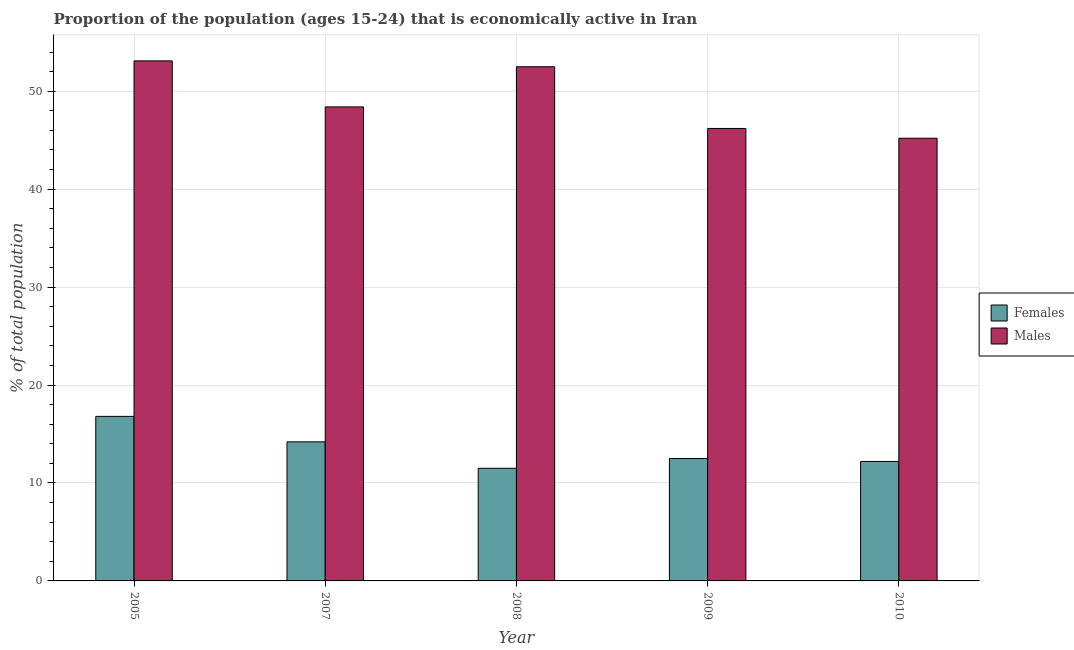How many different coloured bars are there?
Ensure brevity in your answer.  2. How many groups of bars are there?
Your answer should be compact. 5. Are the number of bars per tick equal to the number of legend labels?
Provide a succinct answer. Yes. How many bars are there on the 1st tick from the right?
Provide a short and direct response. 2. In how many cases, is the number of bars for a given year not equal to the number of legend labels?
Your answer should be compact. 0. What is the percentage of economically active male population in 2009?
Give a very brief answer. 46.2. Across all years, what is the maximum percentage of economically active male population?
Give a very brief answer. 53.1. In which year was the percentage of economically active female population maximum?
Offer a terse response. 2005. What is the total percentage of economically active male population in the graph?
Provide a short and direct response. 245.4. What is the difference between the percentage of economically active female population in 2005 and that in 2010?
Ensure brevity in your answer.  4.6. What is the difference between the percentage of economically active female population in 2005 and the percentage of economically active male population in 2009?
Your answer should be very brief. 4.3. What is the average percentage of economically active female population per year?
Give a very brief answer. 13.44. In the year 2010, what is the difference between the percentage of economically active male population and percentage of economically active female population?
Your answer should be very brief. 0. In how many years, is the percentage of economically active male population greater than 44 %?
Provide a succinct answer. 5. What is the ratio of the percentage of economically active male population in 2005 to that in 2009?
Keep it short and to the point. 1.15. Is the difference between the percentage of economically active male population in 2005 and 2010 greater than the difference between the percentage of economically active female population in 2005 and 2010?
Offer a very short reply. No. What is the difference between the highest and the second highest percentage of economically active male population?
Keep it short and to the point. 0.6. What is the difference between the highest and the lowest percentage of economically active female population?
Your answer should be very brief. 5.3. In how many years, is the percentage of economically active female population greater than the average percentage of economically active female population taken over all years?
Make the answer very short. 2. What does the 2nd bar from the left in 2005 represents?
Make the answer very short. Males. What does the 1st bar from the right in 2009 represents?
Your answer should be compact. Males. How many bars are there?
Offer a terse response. 10. Are all the bars in the graph horizontal?
Provide a succinct answer. No. Where does the legend appear in the graph?
Keep it short and to the point. Center right. How many legend labels are there?
Make the answer very short. 2. What is the title of the graph?
Provide a succinct answer. Proportion of the population (ages 15-24) that is economically active in Iran. What is the label or title of the X-axis?
Provide a short and direct response. Year. What is the label or title of the Y-axis?
Offer a terse response. % of total population. What is the % of total population in Females in 2005?
Your answer should be compact. 16.8. What is the % of total population of Males in 2005?
Your answer should be very brief. 53.1. What is the % of total population in Females in 2007?
Your answer should be compact. 14.2. What is the % of total population in Males in 2007?
Offer a terse response. 48.4. What is the % of total population in Females in 2008?
Your response must be concise. 11.5. What is the % of total population in Males in 2008?
Your answer should be compact. 52.5. What is the % of total population of Males in 2009?
Keep it short and to the point. 46.2. What is the % of total population in Females in 2010?
Provide a succinct answer. 12.2. What is the % of total population in Males in 2010?
Provide a succinct answer. 45.2. Across all years, what is the maximum % of total population in Females?
Your answer should be compact. 16.8. Across all years, what is the maximum % of total population of Males?
Offer a terse response. 53.1. Across all years, what is the minimum % of total population of Males?
Offer a terse response. 45.2. What is the total % of total population in Females in the graph?
Offer a very short reply. 67.2. What is the total % of total population of Males in the graph?
Your answer should be very brief. 245.4. What is the difference between the % of total population in Females in 2005 and that in 2007?
Offer a very short reply. 2.6. What is the difference between the % of total population of Males in 2005 and that in 2008?
Make the answer very short. 0.6. What is the difference between the % of total population of Males in 2005 and that in 2009?
Provide a succinct answer. 6.9. What is the difference between the % of total population in Females in 2005 and that in 2010?
Ensure brevity in your answer.  4.6. What is the difference between the % of total population of Females in 2007 and that in 2008?
Offer a very short reply. 2.7. What is the difference between the % of total population of Males in 2007 and that in 2008?
Ensure brevity in your answer.  -4.1. What is the difference between the % of total population in Males in 2007 and that in 2009?
Your answer should be very brief. 2.2. What is the difference between the % of total population of Females in 2008 and that in 2010?
Give a very brief answer. -0.7. What is the difference between the % of total population of Males in 2008 and that in 2010?
Make the answer very short. 7.3. What is the difference between the % of total population of Females in 2009 and that in 2010?
Offer a terse response. 0.3. What is the difference between the % of total population of Females in 2005 and the % of total population of Males in 2007?
Provide a succinct answer. -31.6. What is the difference between the % of total population of Females in 2005 and the % of total population of Males in 2008?
Offer a very short reply. -35.7. What is the difference between the % of total population in Females in 2005 and the % of total population in Males in 2009?
Offer a very short reply. -29.4. What is the difference between the % of total population in Females in 2005 and the % of total population in Males in 2010?
Keep it short and to the point. -28.4. What is the difference between the % of total population in Females in 2007 and the % of total population in Males in 2008?
Your response must be concise. -38.3. What is the difference between the % of total population of Females in 2007 and the % of total population of Males in 2009?
Your answer should be very brief. -32. What is the difference between the % of total population of Females in 2007 and the % of total population of Males in 2010?
Provide a short and direct response. -31. What is the difference between the % of total population in Females in 2008 and the % of total population in Males in 2009?
Your answer should be very brief. -34.7. What is the difference between the % of total population in Females in 2008 and the % of total population in Males in 2010?
Ensure brevity in your answer.  -33.7. What is the difference between the % of total population in Females in 2009 and the % of total population in Males in 2010?
Give a very brief answer. -32.7. What is the average % of total population in Females per year?
Your answer should be very brief. 13.44. What is the average % of total population of Males per year?
Your answer should be very brief. 49.08. In the year 2005, what is the difference between the % of total population in Females and % of total population in Males?
Provide a short and direct response. -36.3. In the year 2007, what is the difference between the % of total population in Females and % of total population in Males?
Keep it short and to the point. -34.2. In the year 2008, what is the difference between the % of total population in Females and % of total population in Males?
Provide a short and direct response. -41. In the year 2009, what is the difference between the % of total population of Females and % of total population of Males?
Provide a short and direct response. -33.7. In the year 2010, what is the difference between the % of total population in Females and % of total population in Males?
Offer a very short reply. -33. What is the ratio of the % of total population of Females in 2005 to that in 2007?
Your response must be concise. 1.18. What is the ratio of the % of total population in Males in 2005 to that in 2007?
Your answer should be very brief. 1.1. What is the ratio of the % of total population of Females in 2005 to that in 2008?
Offer a very short reply. 1.46. What is the ratio of the % of total population of Males in 2005 to that in 2008?
Make the answer very short. 1.01. What is the ratio of the % of total population of Females in 2005 to that in 2009?
Give a very brief answer. 1.34. What is the ratio of the % of total population in Males in 2005 to that in 2009?
Provide a short and direct response. 1.15. What is the ratio of the % of total population in Females in 2005 to that in 2010?
Offer a very short reply. 1.38. What is the ratio of the % of total population of Males in 2005 to that in 2010?
Provide a succinct answer. 1.17. What is the ratio of the % of total population in Females in 2007 to that in 2008?
Your response must be concise. 1.23. What is the ratio of the % of total population in Males in 2007 to that in 2008?
Ensure brevity in your answer.  0.92. What is the ratio of the % of total population in Females in 2007 to that in 2009?
Make the answer very short. 1.14. What is the ratio of the % of total population of Males in 2007 to that in 2009?
Your answer should be compact. 1.05. What is the ratio of the % of total population in Females in 2007 to that in 2010?
Your answer should be very brief. 1.16. What is the ratio of the % of total population in Males in 2007 to that in 2010?
Provide a short and direct response. 1.07. What is the ratio of the % of total population in Males in 2008 to that in 2009?
Make the answer very short. 1.14. What is the ratio of the % of total population of Females in 2008 to that in 2010?
Offer a very short reply. 0.94. What is the ratio of the % of total population of Males in 2008 to that in 2010?
Your response must be concise. 1.16. What is the ratio of the % of total population of Females in 2009 to that in 2010?
Offer a very short reply. 1.02. What is the ratio of the % of total population of Males in 2009 to that in 2010?
Provide a succinct answer. 1.02. What is the difference between the highest and the lowest % of total population of Females?
Offer a very short reply. 5.3. What is the difference between the highest and the lowest % of total population of Males?
Give a very brief answer. 7.9. 